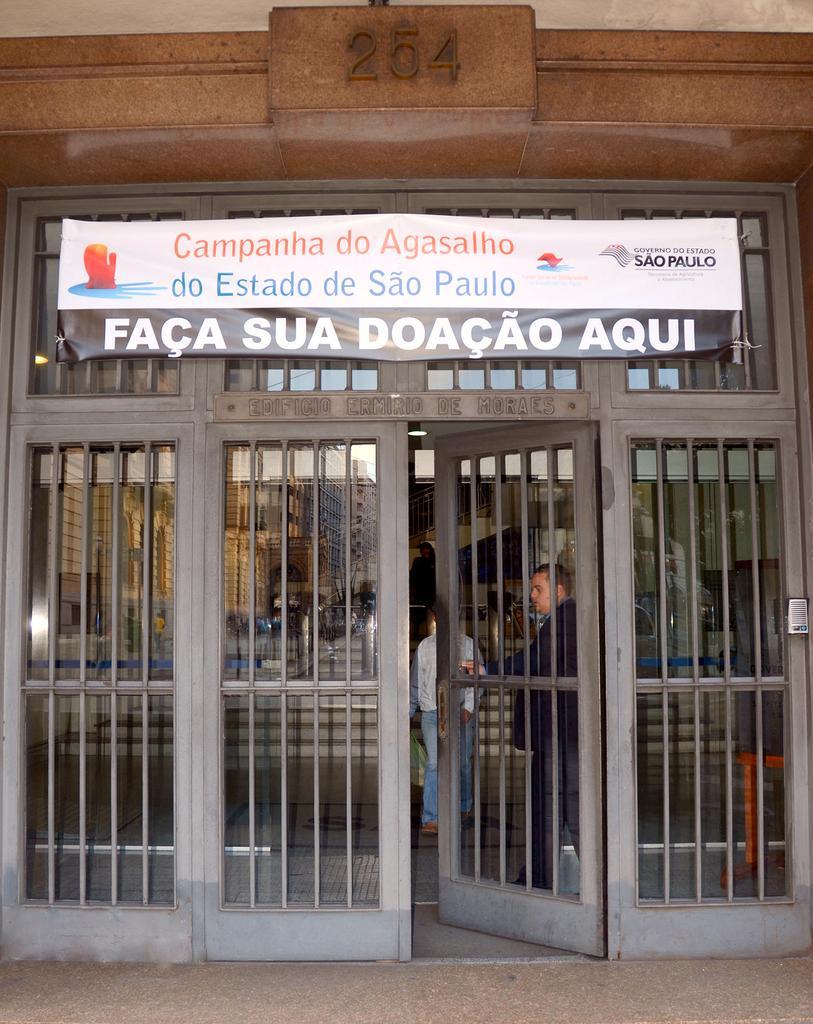In one or two sentences, can you explain what this image depicts? In this image there is an entrance of a house. There are glass doors. On the other side of the door there is a grill. There are numbers on the wall. There is a banner with text on the door. The door is open. Inside the room there are a few people standing. 